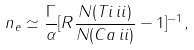Convert formula to latex. <formula><loc_0><loc_0><loc_500><loc_500>n _ { e } \simeq \frac { \Gamma } { \alpha } [ R \frac { N ( T i \, { i i } ) } { N ( C a \, { i i } ) } - 1 ] ^ { - 1 } ,</formula> 